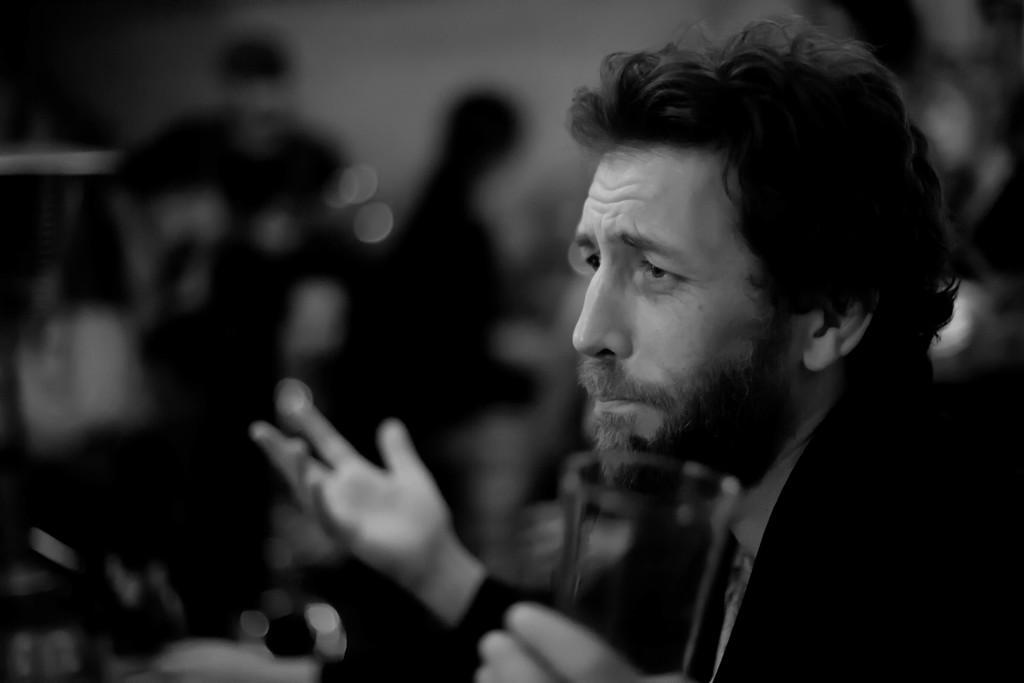Please provide a concise description of this image. This is a black and white image. In this image we can see a person holding a glass. 